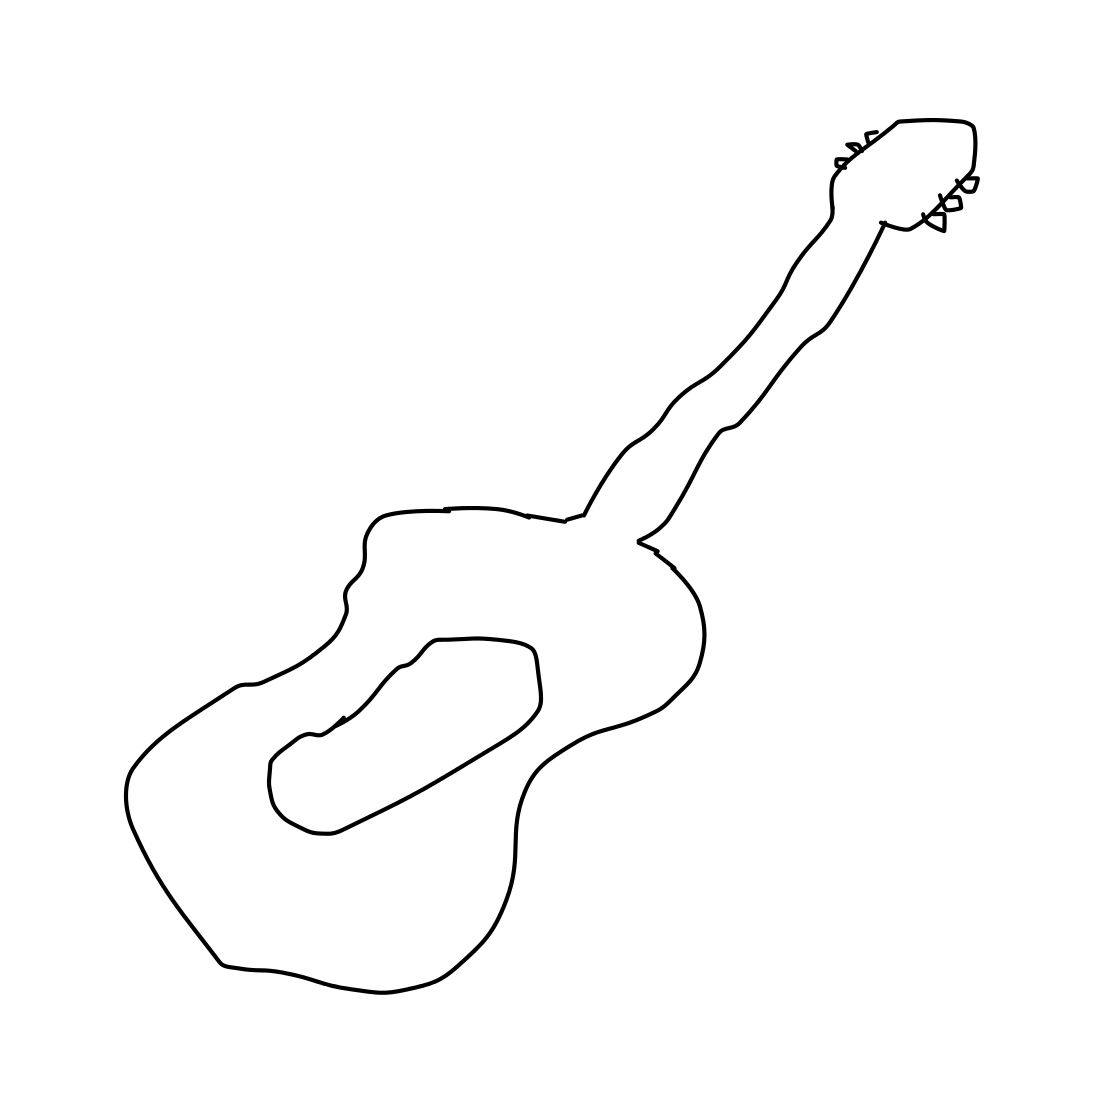Can you describe any unique features of the guitar shown? The guitar has a gracefully curving body and a narrow neck, which ends in a headstock with detailed tuning pegs. This suggests a delicate and precise design, typical of classical guitars. 